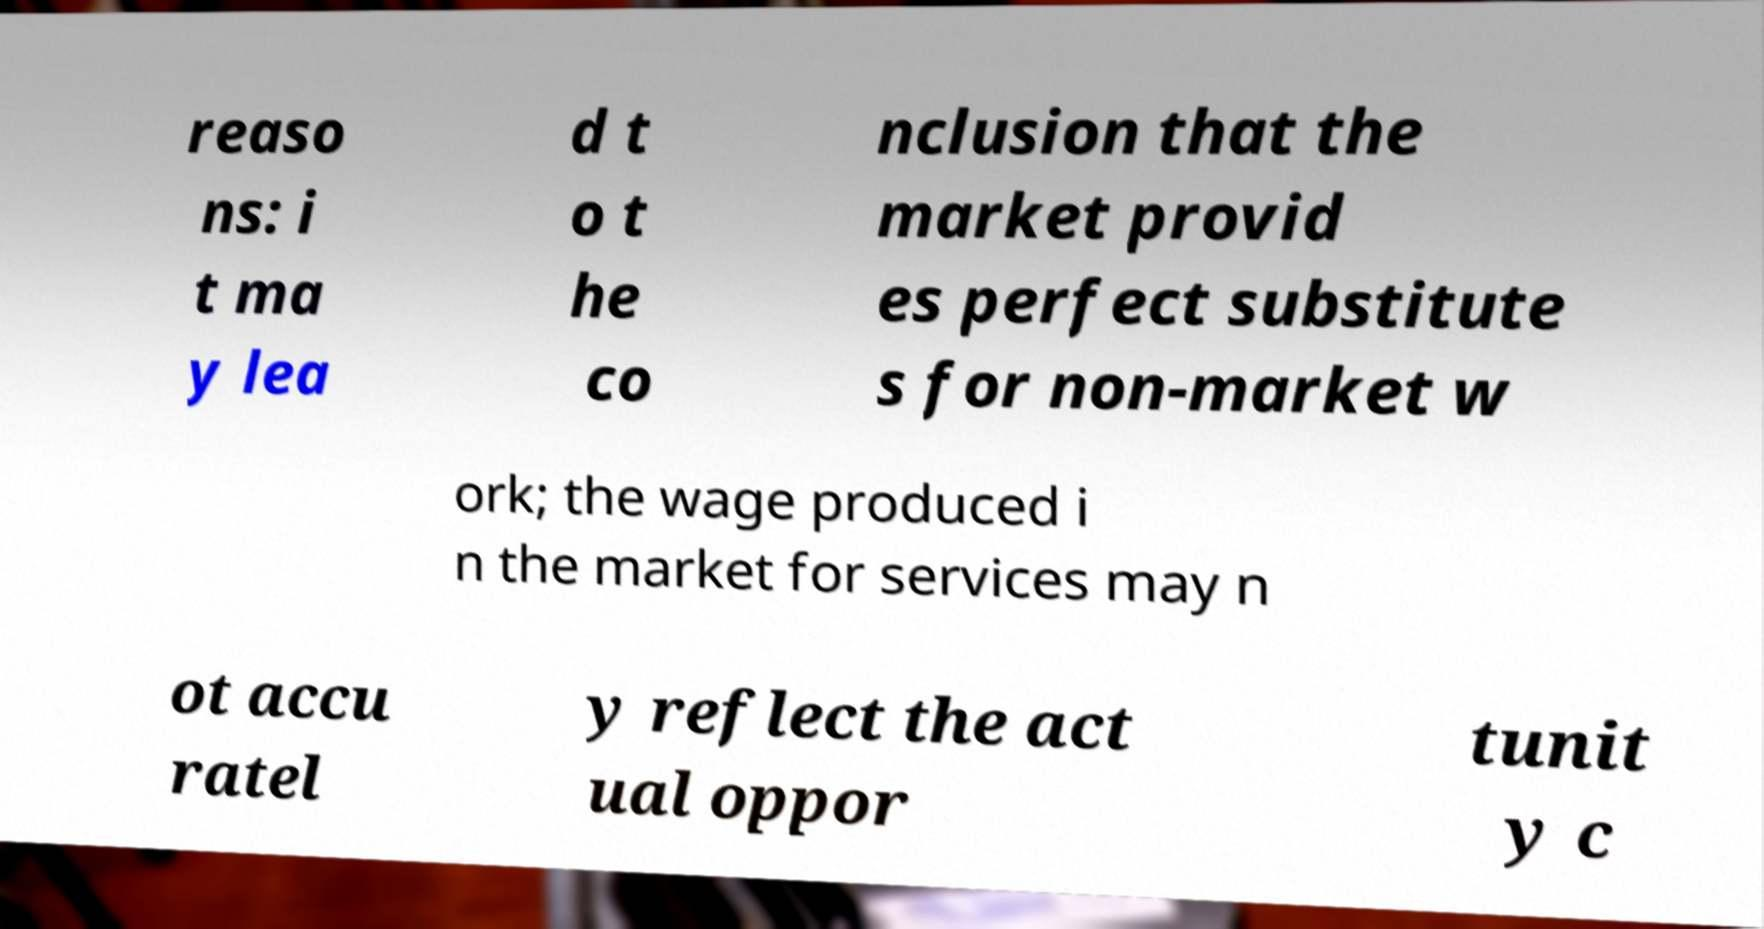Could you extract and type out the text from this image? reaso ns: i t ma y lea d t o t he co nclusion that the market provid es perfect substitute s for non-market w ork; the wage produced i n the market for services may n ot accu ratel y reflect the act ual oppor tunit y c 